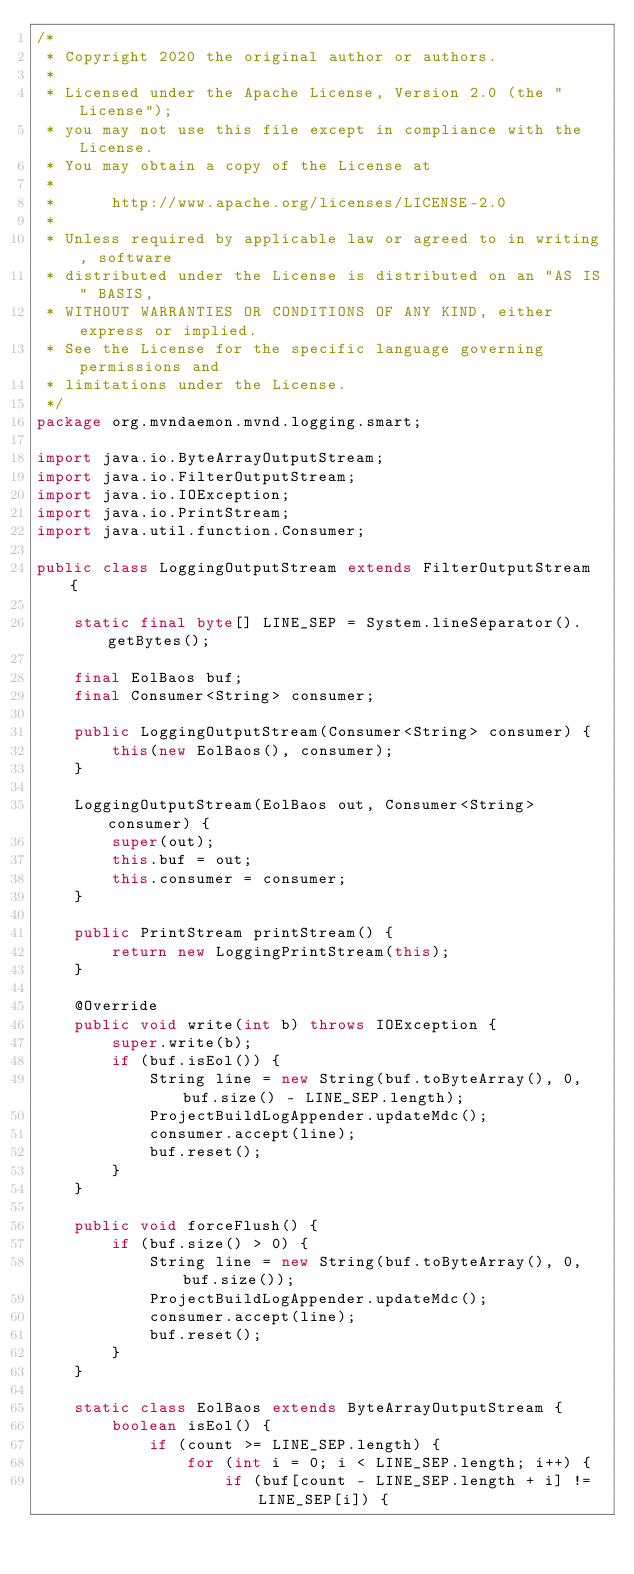Convert code to text. <code><loc_0><loc_0><loc_500><loc_500><_Java_>/*
 * Copyright 2020 the original author or authors.
 *
 * Licensed under the Apache License, Version 2.0 (the "License");
 * you may not use this file except in compliance with the License.
 * You may obtain a copy of the License at
 *
 *      http://www.apache.org/licenses/LICENSE-2.0
 *
 * Unless required by applicable law or agreed to in writing, software
 * distributed under the License is distributed on an "AS IS" BASIS,
 * WITHOUT WARRANTIES OR CONDITIONS OF ANY KIND, either express or implied.
 * See the License for the specific language governing permissions and
 * limitations under the License.
 */
package org.mvndaemon.mvnd.logging.smart;

import java.io.ByteArrayOutputStream;
import java.io.FilterOutputStream;
import java.io.IOException;
import java.io.PrintStream;
import java.util.function.Consumer;

public class LoggingOutputStream extends FilterOutputStream {

    static final byte[] LINE_SEP = System.lineSeparator().getBytes();

    final EolBaos buf;
    final Consumer<String> consumer;

    public LoggingOutputStream(Consumer<String> consumer) {
        this(new EolBaos(), consumer);
    }

    LoggingOutputStream(EolBaos out, Consumer<String> consumer) {
        super(out);
        this.buf = out;
        this.consumer = consumer;
    }

    public PrintStream printStream() {
        return new LoggingPrintStream(this);
    }

    @Override
    public void write(int b) throws IOException {
        super.write(b);
        if (buf.isEol()) {
            String line = new String(buf.toByteArray(), 0, buf.size() - LINE_SEP.length);
            ProjectBuildLogAppender.updateMdc();
            consumer.accept(line);
            buf.reset();
        }
    }

    public void forceFlush() {
        if (buf.size() > 0) {
            String line = new String(buf.toByteArray(), 0, buf.size());
            ProjectBuildLogAppender.updateMdc();
            consumer.accept(line);
            buf.reset();
        }
    }

    static class EolBaos extends ByteArrayOutputStream {
        boolean isEol() {
            if (count >= LINE_SEP.length) {
                for (int i = 0; i < LINE_SEP.length; i++) {
                    if (buf[count - LINE_SEP.length + i] != LINE_SEP[i]) {</code> 